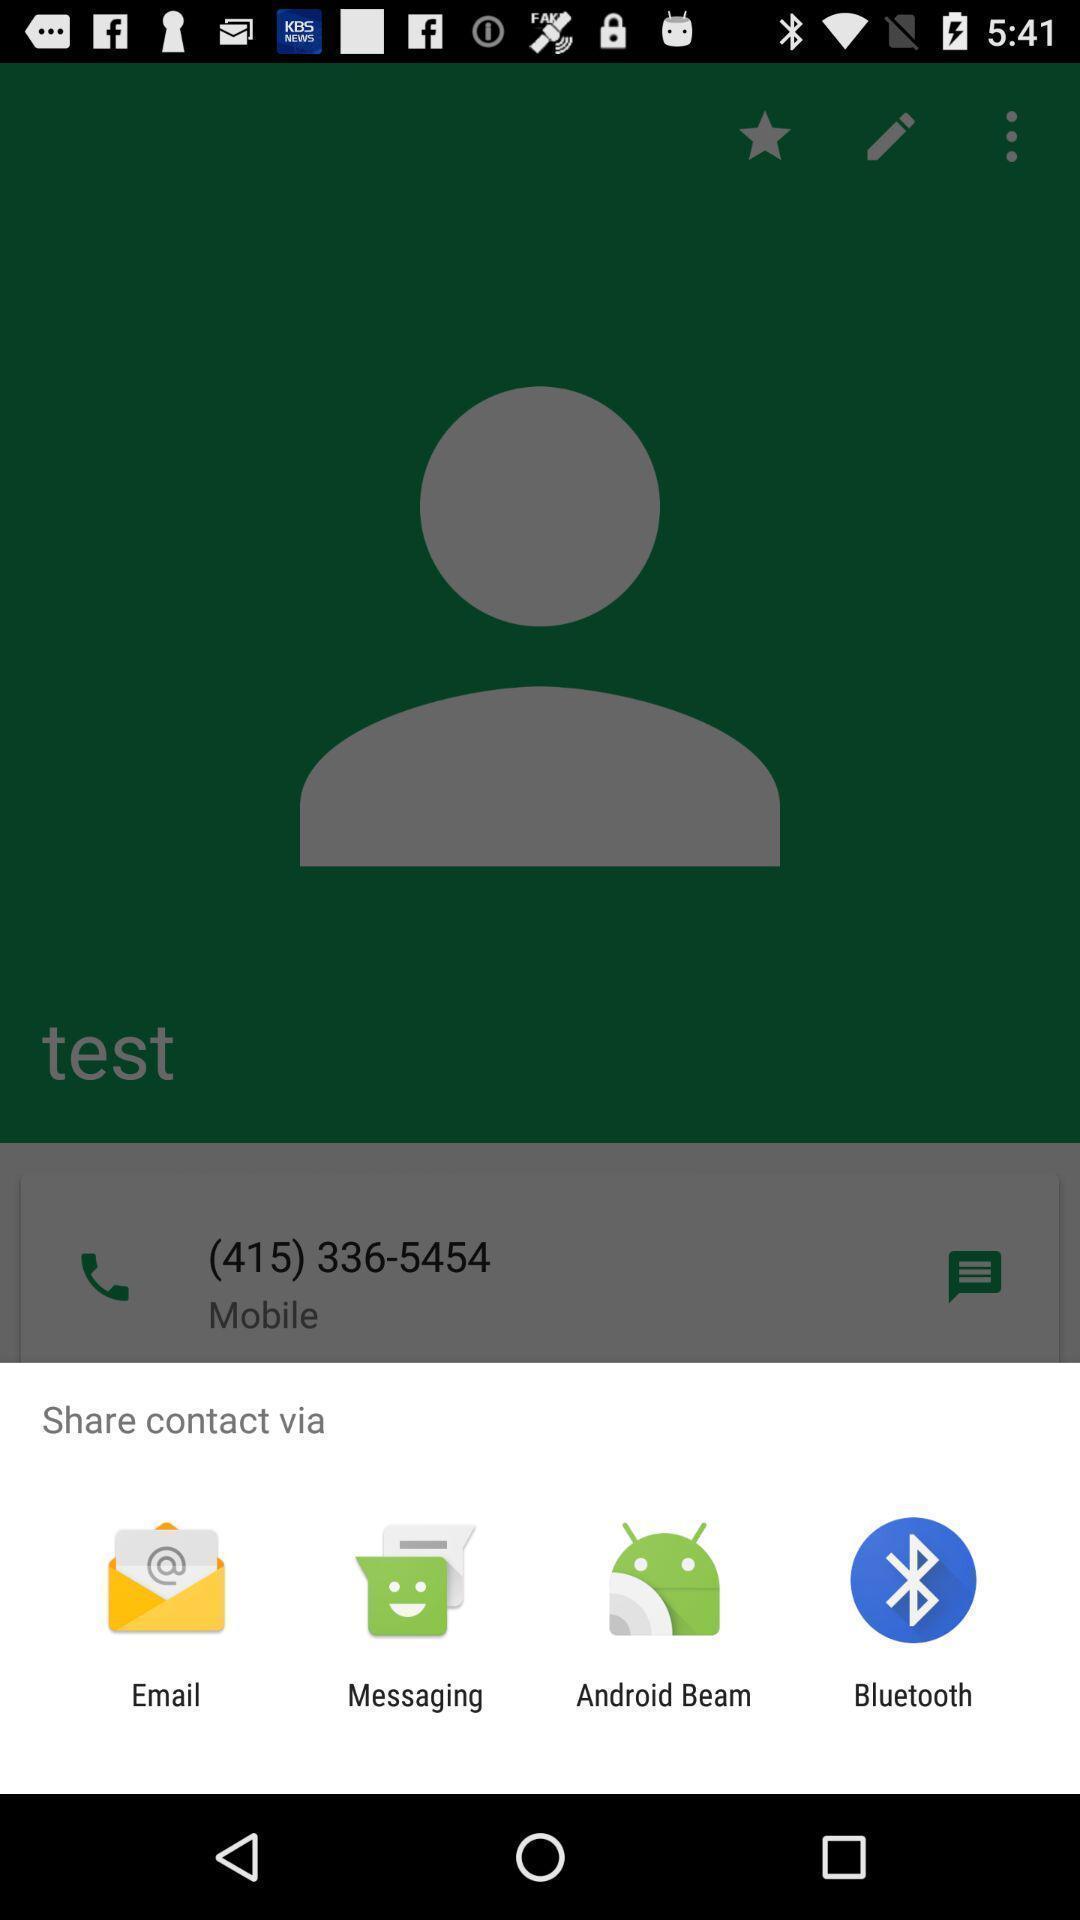Please provide a description for this image. Pop-up to share contact via different apps. 